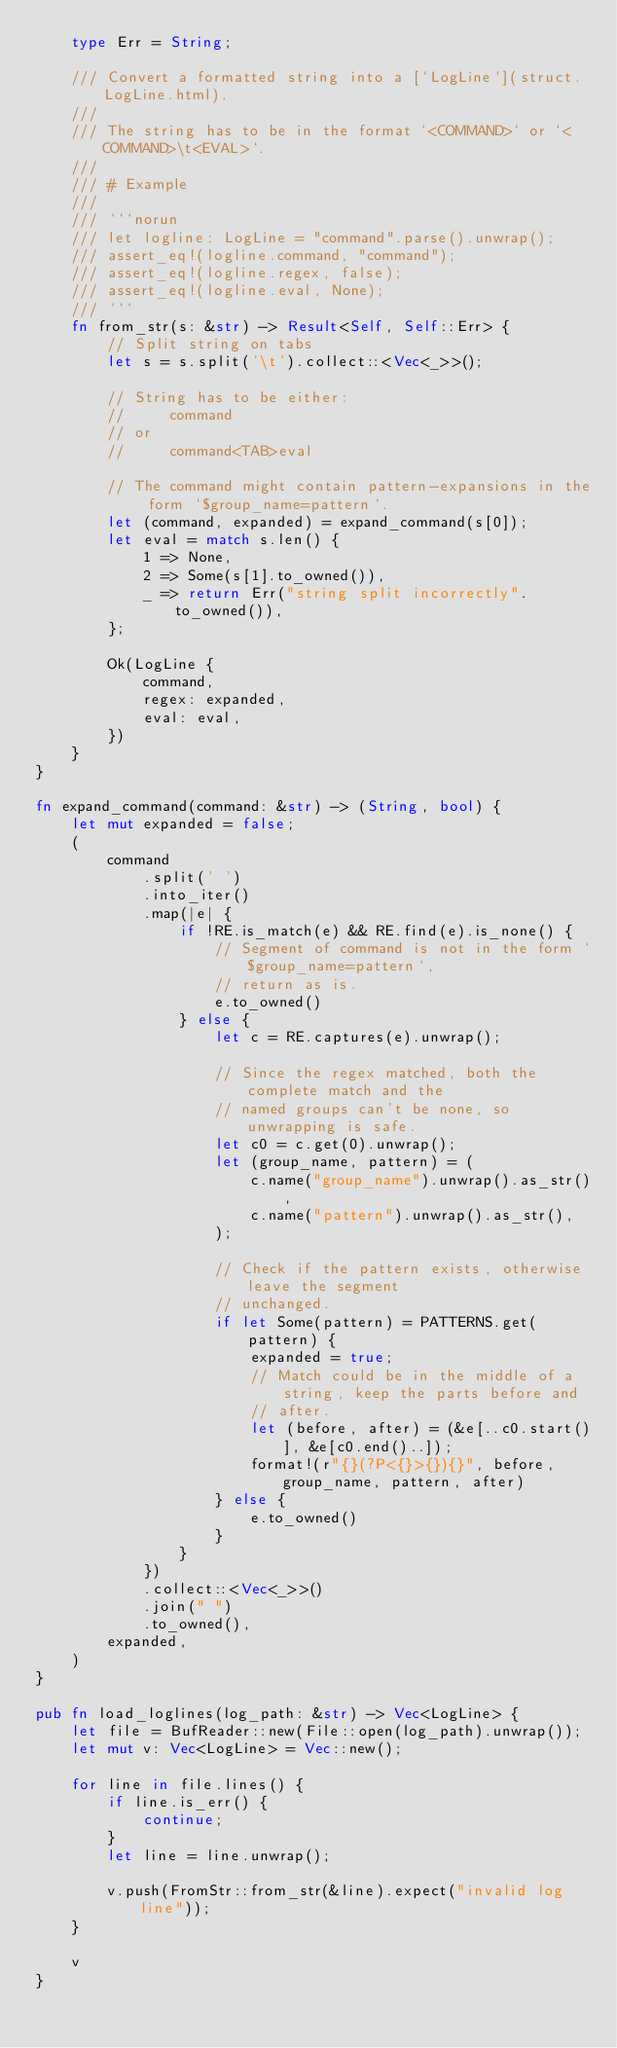<code> <loc_0><loc_0><loc_500><loc_500><_Rust_>    type Err = String;

    /// Convert a formatted string into a [`LogLine`](struct.LogLine.html).
    ///
    /// The string has to be in the format `<COMMAND>` or `<COMMAND>\t<EVAL>`.
    ///
    /// # Example
    ///
    /// ```norun
    /// let logline: LogLine = "command".parse().unwrap();
    /// assert_eq!(logline.command, "command");
    /// assert_eq!(logline.regex, false);
    /// assert_eq!(logline.eval, None);
    /// ```
    fn from_str(s: &str) -> Result<Self, Self::Err> {
        // Split string on tabs
        let s = s.split('\t').collect::<Vec<_>>();

        // String has to be either:
        //     command
        // or
        //     command<TAB>eval

        // The command might contain pattern-expansions in the form `$group_name=pattern`.
        let (command, expanded) = expand_command(s[0]);
        let eval = match s.len() {
            1 => None,
            2 => Some(s[1].to_owned()),
            _ => return Err("string split incorrectly".to_owned()),
        };

        Ok(LogLine {
            command,
            regex: expanded,
            eval: eval,
        })
    }
}

fn expand_command(command: &str) -> (String, bool) {
    let mut expanded = false;
    (
        command
            .split(' ')
            .into_iter()
            .map(|e| {
                if !RE.is_match(e) && RE.find(e).is_none() {
                    // Segment of command is not in the form `$group_name=pattern`,
                    // return as is.
                    e.to_owned()
                } else {
                    let c = RE.captures(e).unwrap();

                    // Since the regex matched, both the complete match and the
                    // named groups can't be none, so unwrapping is safe.
                    let c0 = c.get(0).unwrap();
                    let (group_name, pattern) = (
                        c.name("group_name").unwrap().as_str(),
                        c.name("pattern").unwrap().as_str(),
                    );

                    // Check if the pattern exists, otherwise leave the segment
                    // unchanged.
                    if let Some(pattern) = PATTERNS.get(pattern) {
                        expanded = true;
                        // Match could be in the middle of a string, keep the parts before and
                        // after.
                        let (before, after) = (&e[..c0.start()], &e[c0.end()..]);
                        format!(r"{}(?P<{}>{}){}", before, group_name, pattern, after)
                    } else {
                        e.to_owned()
                    }
                }
            })
            .collect::<Vec<_>>()
            .join(" ")
            .to_owned(),
        expanded,
    )
}

pub fn load_loglines(log_path: &str) -> Vec<LogLine> {
    let file = BufReader::new(File::open(log_path).unwrap());
    let mut v: Vec<LogLine> = Vec::new();

    for line in file.lines() {
        if line.is_err() {
            continue;
        }
        let line = line.unwrap();

        v.push(FromStr::from_str(&line).expect("invalid log line"));
    }

    v
}
</code> 